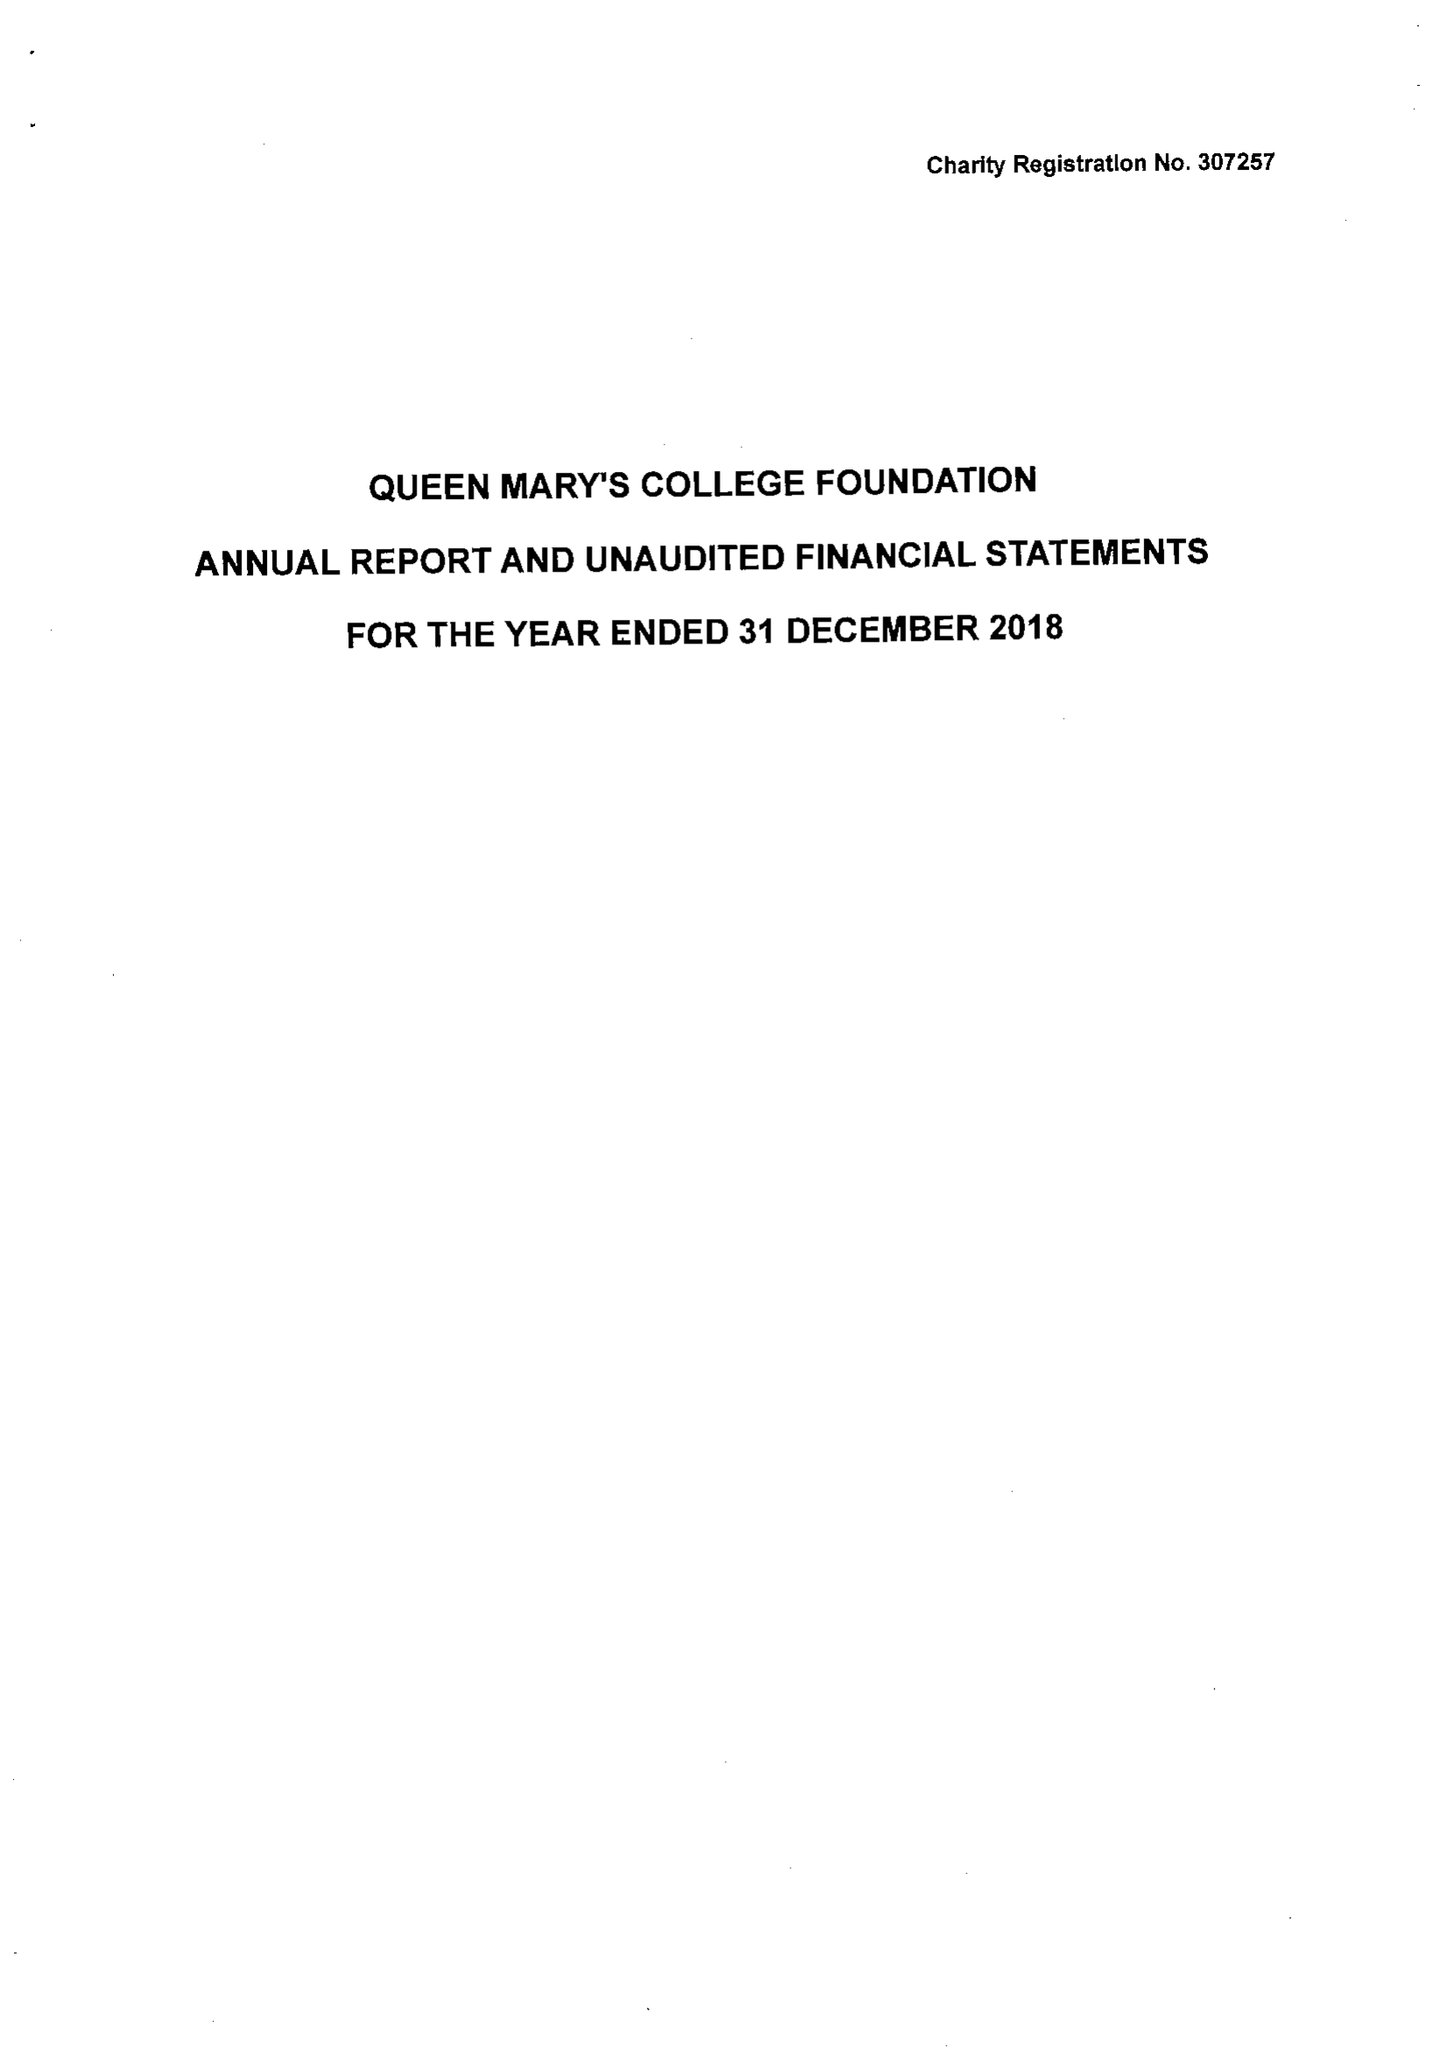What is the value for the report_date?
Answer the question using a single word or phrase. 2018-12-31 